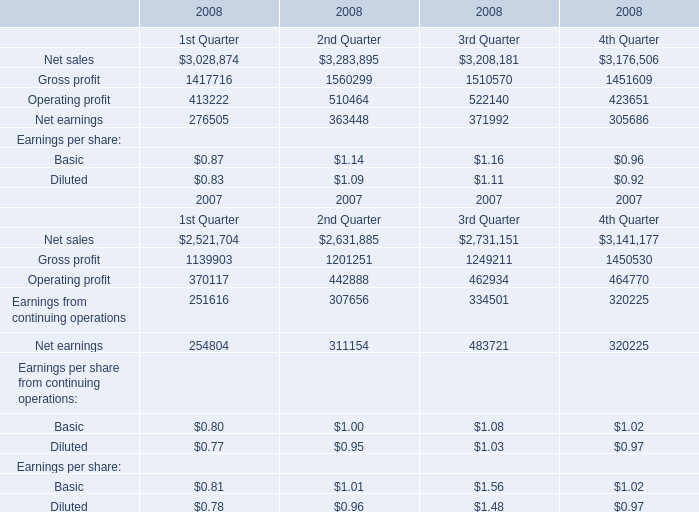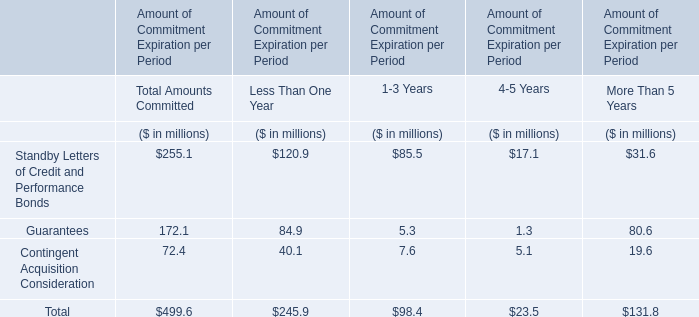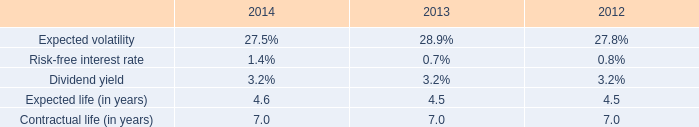What was the sum of Net sales without those elements smaller than 3200000 in 2008? 
Computations: (3283895 + 3208181)
Answer: 6492076.0. 